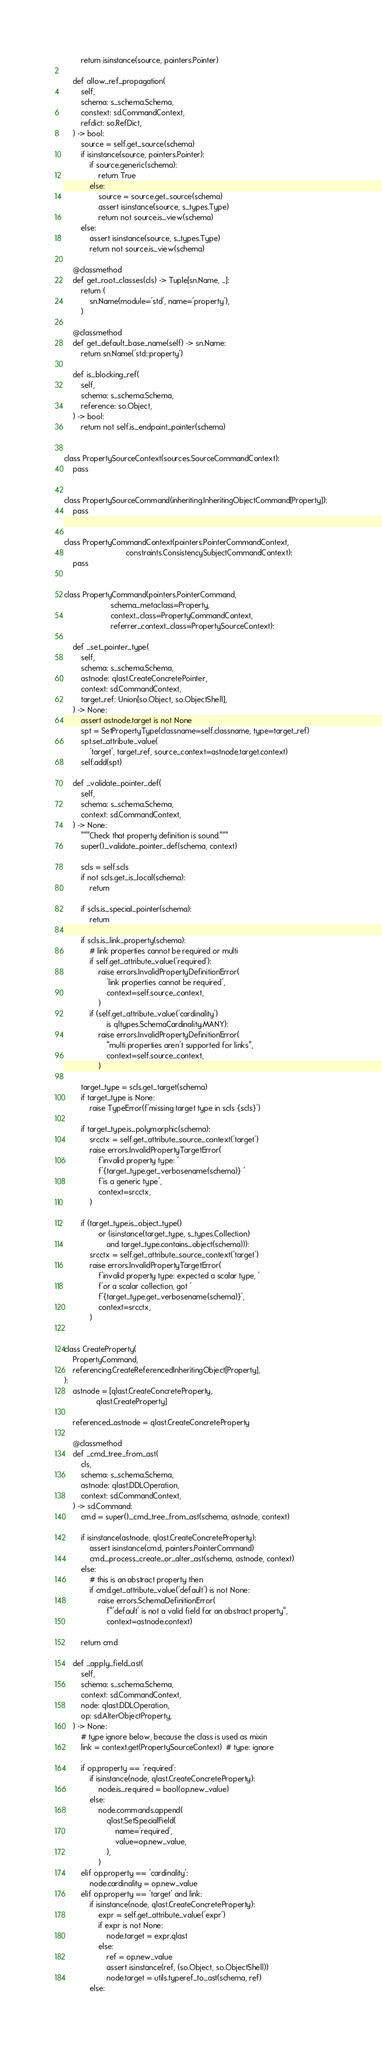Convert code to text. <code><loc_0><loc_0><loc_500><loc_500><_Python_>        return isinstance(source, pointers.Pointer)

    def allow_ref_propagation(
        self,
        schema: s_schema.Schema,
        constext: sd.CommandContext,
        refdict: so.RefDict,
    ) -> bool:
        source = self.get_source(schema)
        if isinstance(source, pointers.Pointer):
            if source.generic(schema):
                return True
            else:
                source = source.get_source(schema)
                assert isinstance(source, s_types.Type)
                return not source.is_view(schema)
        else:
            assert isinstance(source, s_types.Type)
            return not source.is_view(schema)

    @classmethod
    def get_root_classes(cls) -> Tuple[sn.Name, ...]:
        return (
            sn.Name(module='std', name='property'),
        )

    @classmethod
    def get_default_base_name(self) -> sn.Name:
        return sn.Name('std::property')

    def is_blocking_ref(
        self,
        schema: s_schema.Schema,
        reference: so.Object,
    ) -> bool:
        return not self.is_endpoint_pointer(schema)


class PropertySourceContext(sources.SourceCommandContext):
    pass


class PropertySourceCommand(inheriting.InheritingObjectCommand[Property]):
    pass


class PropertyCommandContext(pointers.PointerCommandContext,
                             constraints.ConsistencySubjectCommandContext):
    pass


class PropertyCommand(pointers.PointerCommand,
                      schema_metaclass=Property,
                      context_class=PropertyCommandContext,
                      referrer_context_class=PropertySourceContext):

    def _set_pointer_type(
        self,
        schema: s_schema.Schema,
        astnode: qlast.CreateConcretePointer,
        context: sd.CommandContext,
        target_ref: Union[so.Object, so.ObjectShell],
    ) -> None:
        assert astnode.target is not None
        spt = SetPropertyType(classname=self.classname, type=target_ref)
        spt.set_attribute_value(
            'target', target_ref, source_context=astnode.target.context)
        self.add(spt)

    def _validate_pointer_def(
        self,
        schema: s_schema.Schema,
        context: sd.CommandContext,
    ) -> None:
        """Check that property definition is sound."""
        super()._validate_pointer_def(schema, context)

        scls = self.scls
        if not scls.get_is_local(schema):
            return

        if scls.is_special_pointer(schema):
            return

        if scls.is_link_property(schema):
            # link properties cannot be required or multi
            if self.get_attribute_value('required'):
                raise errors.InvalidPropertyDefinitionError(
                    'link properties cannot be required',
                    context=self.source_context,
                )
            if (self.get_attribute_value('cardinality')
                    is qltypes.SchemaCardinality.MANY):
                raise errors.InvalidPropertyDefinitionError(
                    "multi properties aren't supported for links",
                    context=self.source_context,
                )

        target_type = scls.get_target(schema)
        if target_type is None:
            raise TypeError(f'missing target type in scls {scls}')

        if target_type.is_polymorphic(schema):
            srcctx = self.get_attribute_source_context('target')
            raise errors.InvalidPropertyTargetError(
                f'invalid property type: '
                f'{target_type.get_verbosename(schema)} '
                f'is a generic type',
                context=srcctx,
            )

        if (target_type.is_object_type()
                or (isinstance(target_type, s_types.Collection)
                    and target_type.contains_object(schema))):
            srcctx = self.get_attribute_source_context('target')
            raise errors.InvalidPropertyTargetError(
                f'invalid property type: expected a scalar type, '
                f'or a scalar collection, got '
                f'{target_type.get_verbosename(schema)}',
                context=srcctx,
            )


class CreateProperty(
    PropertyCommand,
    referencing.CreateReferencedInheritingObject[Property],
):
    astnode = [qlast.CreateConcreteProperty,
               qlast.CreateProperty]

    referenced_astnode = qlast.CreateConcreteProperty

    @classmethod
    def _cmd_tree_from_ast(
        cls,
        schema: s_schema.Schema,
        astnode: qlast.DDLOperation,
        context: sd.CommandContext,
    ) -> sd.Command:
        cmd = super()._cmd_tree_from_ast(schema, astnode, context)

        if isinstance(astnode, qlast.CreateConcreteProperty):
            assert isinstance(cmd, pointers.PointerCommand)
            cmd._process_create_or_alter_ast(schema, astnode, context)
        else:
            # this is an abstract property then
            if cmd.get_attribute_value('default') is not None:
                raise errors.SchemaDefinitionError(
                    f"'default' is not a valid field for an abstract property",
                    context=astnode.context)

        return cmd

    def _apply_field_ast(
        self,
        schema: s_schema.Schema,
        context: sd.CommandContext,
        node: qlast.DDLOperation,
        op: sd.AlterObjectProperty,
    ) -> None:
        # type ignore below, because the class is used as mixin
        link = context.get(PropertySourceContext)  # type: ignore

        if op.property == 'required':
            if isinstance(node, qlast.CreateConcreteProperty):
                node.is_required = bool(op.new_value)
            else:
                node.commands.append(
                    qlast.SetSpecialField(
                        name='required',
                        value=op.new_value,
                    ),
                )
        elif op.property == 'cardinality':
            node.cardinality = op.new_value
        elif op.property == 'target' and link:
            if isinstance(node, qlast.CreateConcreteProperty):
                expr = self.get_attribute_value('expr')
                if expr is not None:
                    node.target = expr.qlast
                else:
                    ref = op.new_value
                    assert isinstance(ref, (so.Object, so.ObjectShell))
                    node.target = utils.typeref_to_ast(schema, ref)
            else:</code> 